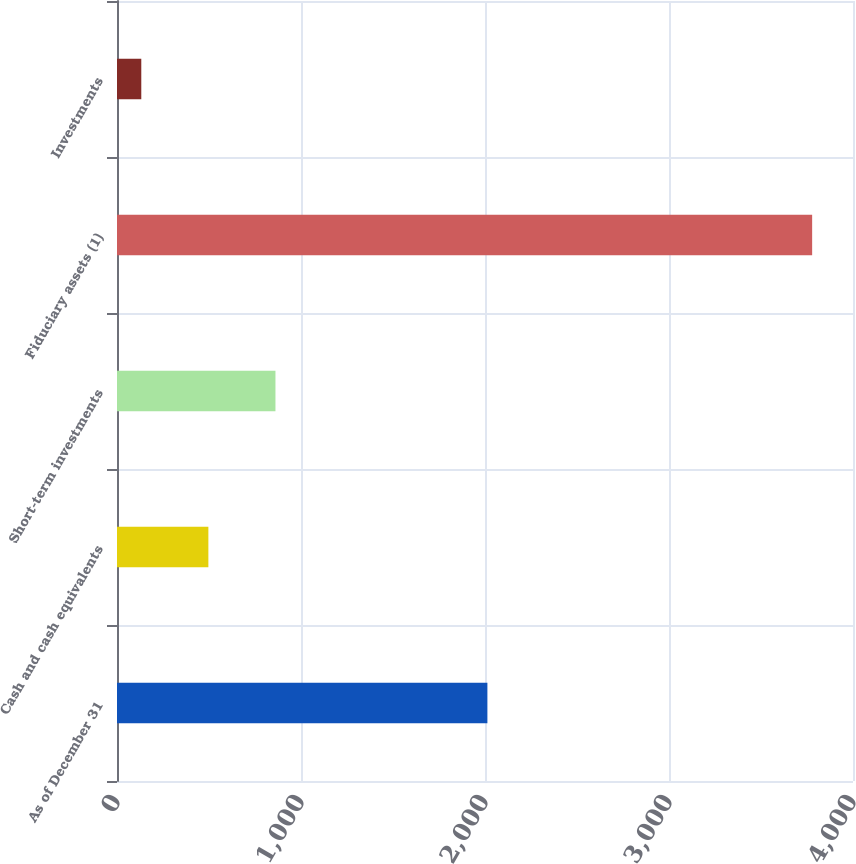Convert chart. <chart><loc_0><loc_0><loc_500><loc_500><bar_chart><fcel>As of December 31<fcel>Cash and cash equivalents<fcel>Short-term investments<fcel>Fiduciary assets (1)<fcel>Investments<nl><fcel>2013<fcel>496.6<fcel>861.2<fcel>3778<fcel>132<nl></chart> 